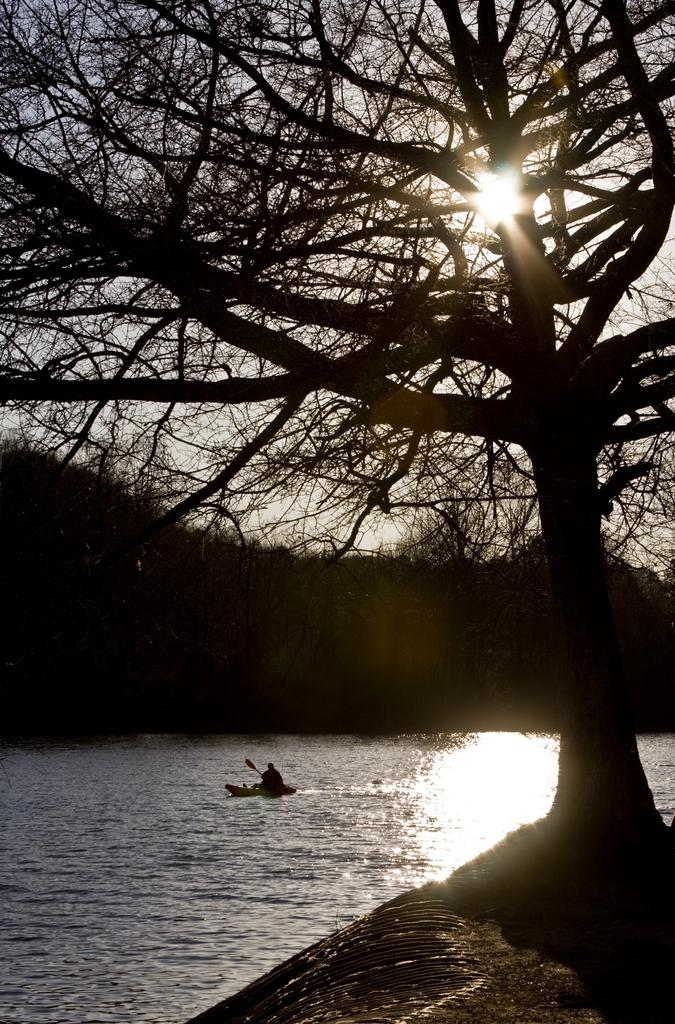What is the person in the image doing? There is a person sailing a boat in the image. How is the person sailing the boat? The person is using a row to sail the boat. What type of environment is visible in the image? There is water, a group of trees, and the sky visible in the image. What degree of respect does the person in the image have for the apparatus they are using? There is no apparatus mentioned in the image, and the concept of respect is not applicable to the image. 